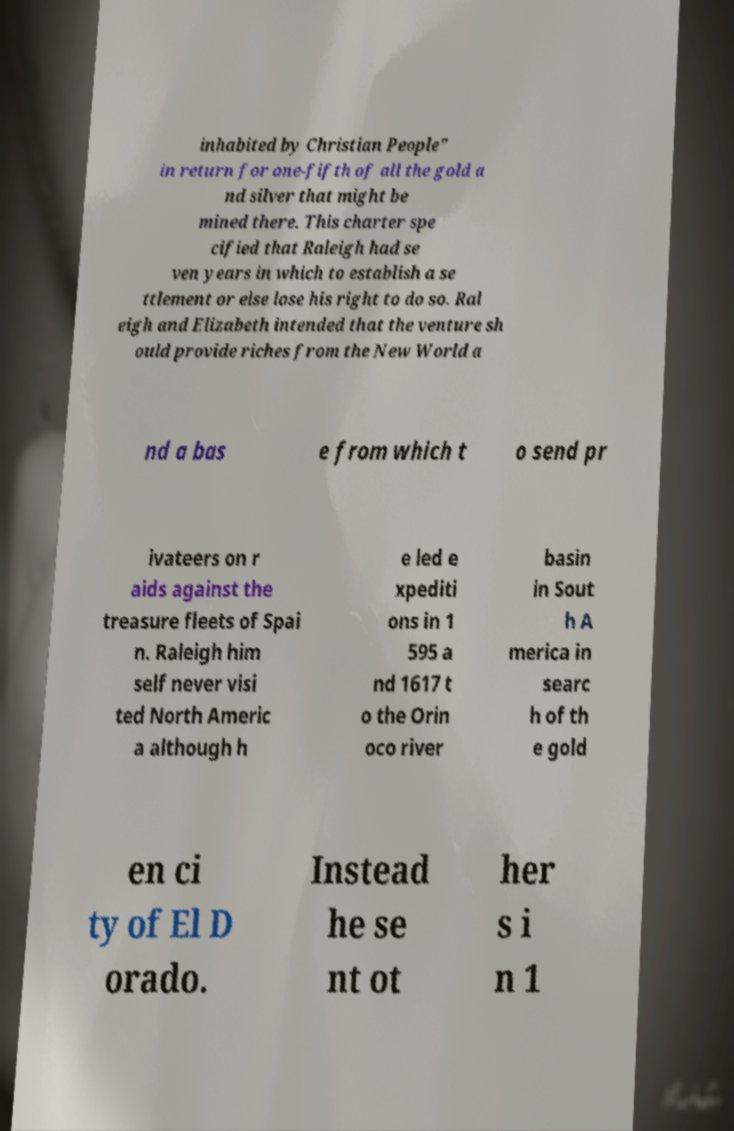Please read and relay the text visible in this image. What does it say? inhabited by Christian People" in return for one-fifth of all the gold a nd silver that might be mined there. This charter spe cified that Raleigh had se ven years in which to establish a se ttlement or else lose his right to do so. Ral eigh and Elizabeth intended that the venture sh ould provide riches from the New World a nd a bas e from which t o send pr ivateers on r aids against the treasure fleets of Spai n. Raleigh him self never visi ted North Americ a although h e led e xpediti ons in 1 595 a nd 1617 t o the Orin oco river basin in Sout h A merica in searc h of th e gold en ci ty of El D orado. Instead he se nt ot her s i n 1 